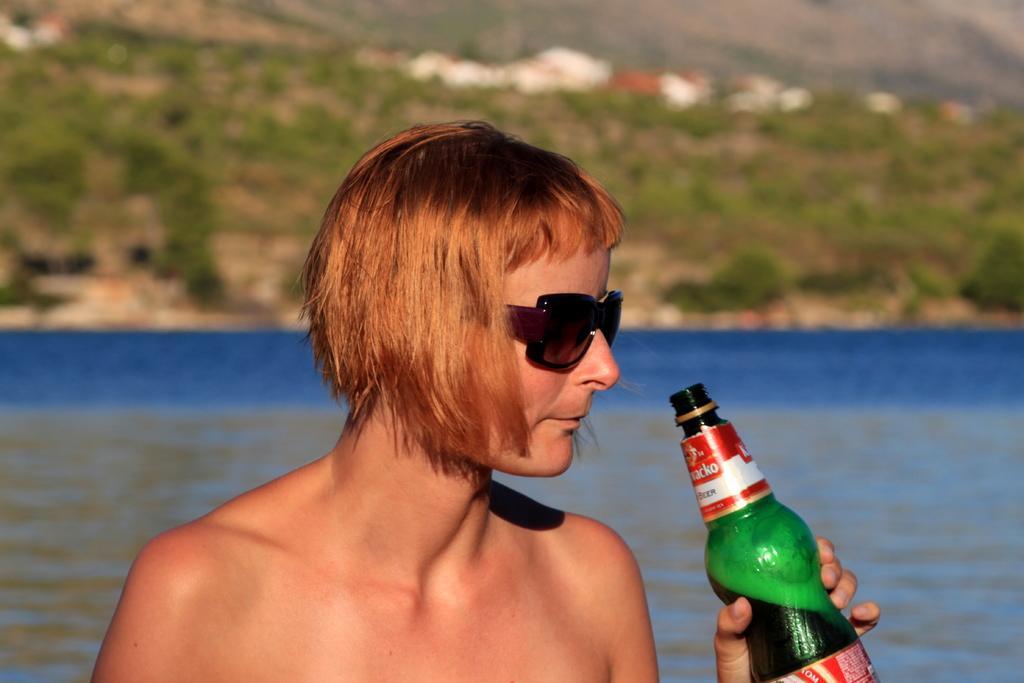Please provide a concise description of this image. This image is clicked outside. There is water in the back side and there is a person standing. He is holding a bottle in his hand. He is wearing goggles. 